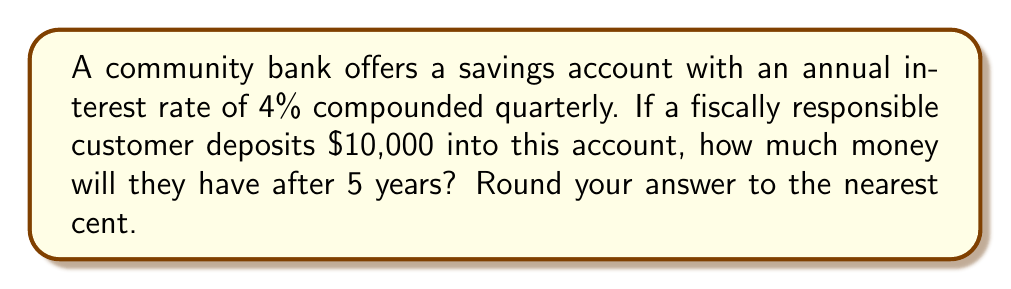Give your solution to this math problem. To solve this problem, we'll use the compound interest formula:

$$A = P(1 + \frac{r}{n})^{nt}$$

Where:
$A$ = final amount
$P$ = principal (initial investment)
$r$ = annual interest rate (as a decimal)
$n$ = number of times interest is compounded per year
$t$ = number of years

Given:
$P = \$10,000$
$r = 0.04$ (4% expressed as a decimal)
$n = 4$ (compounded quarterly, so 4 times per year)
$t = 5$ years

Let's substitute these values into the formula:

$$A = 10000(1 + \frac{0.04}{4})^{4 \cdot 5}$$

$$A = 10000(1 + 0.01)^{20}$$

$$A = 10000(1.01)^{20}$$

Using a calculator or computer:

$$A = 10000 \cdot 1.2201898$$ 

$$A = 12201.898$$

Rounding to the nearest cent:

$$A = \$12,201.90$$
Answer: $12,201.90 